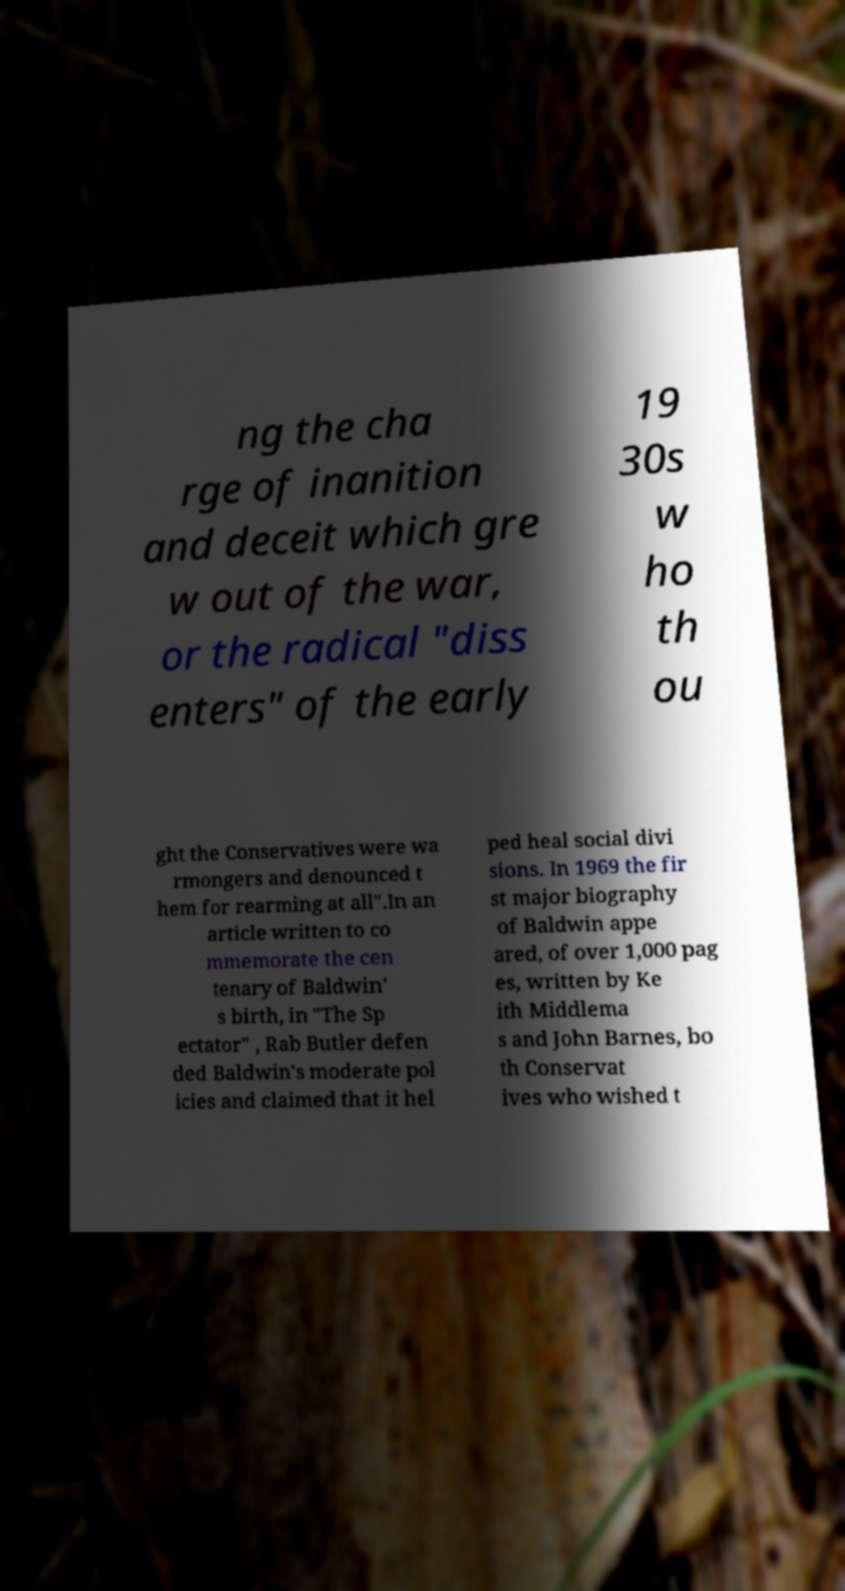Please read and relay the text visible in this image. What does it say? ng the cha rge of inanition and deceit which gre w out of the war, or the radical "diss enters" of the early 19 30s w ho th ou ght the Conservatives were wa rmongers and denounced t hem for rearming at all".In an article written to co mmemorate the cen tenary of Baldwin' s birth, in "The Sp ectator" , Rab Butler defen ded Baldwin's moderate pol icies and claimed that it hel ped heal social divi sions. In 1969 the fir st major biography of Baldwin appe ared, of over 1,000 pag es, written by Ke ith Middlema s and John Barnes, bo th Conservat ives who wished t 